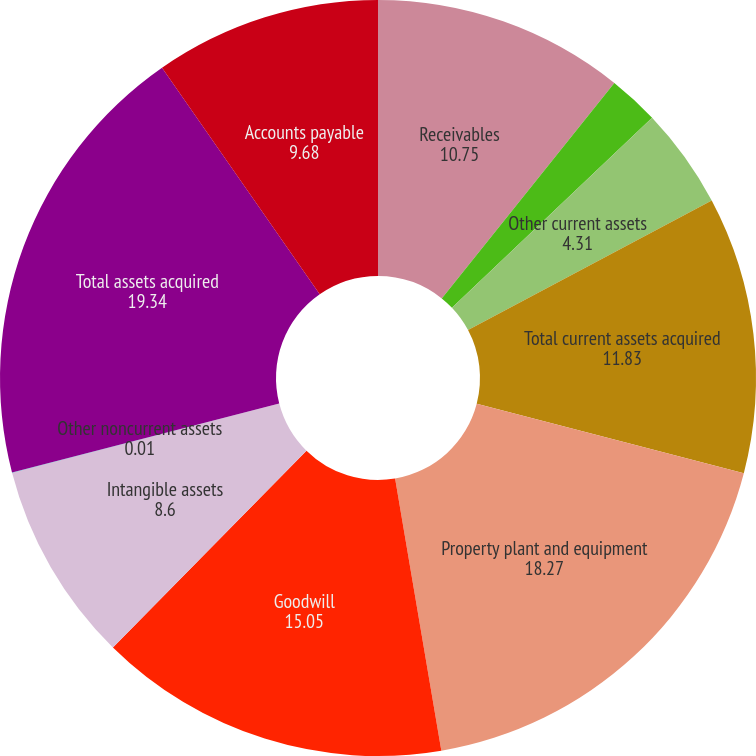<chart> <loc_0><loc_0><loc_500><loc_500><pie_chart><fcel>Receivables<fcel>Inventories<fcel>Other current assets<fcel>Total current assets acquired<fcel>Property plant and equipment<fcel>Goodwill<fcel>Intangible assets<fcel>Other noncurrent assets<fcel>Total assets acquired<fcel>Accounts payable<nl><fcel>10.75%<fcel>2.16%<fcel>4.31%<fcel>11.83%<fcel>18.27%<fcel>15.05%<fcel>8.6%<fcel>0.01%<fcel>19.34%<fcel>9.68%<nl></chart> 